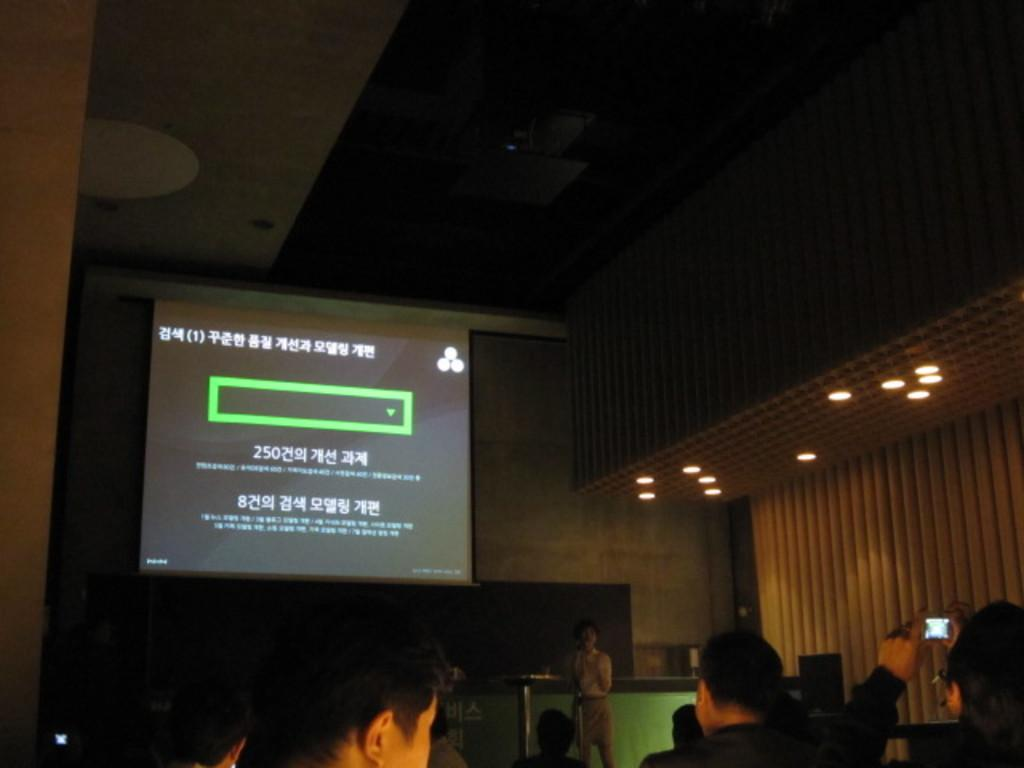What is the main object in the image? There is a screen in the image. Can you describe the people in the image? There are people visible in the image. What is the person in the front of the image doing? A person is standing and talking in the front of the image. What type of structure is present in the image? There is a roof in the image. What can be used to illuminate the area in the image? There is a light in the image. What type of hole can be seen in the image? There is no hole present in the image. How does the sun affect the lighting in the image? The image does not show the sun, so its effect on the lighting cannot be determined. 